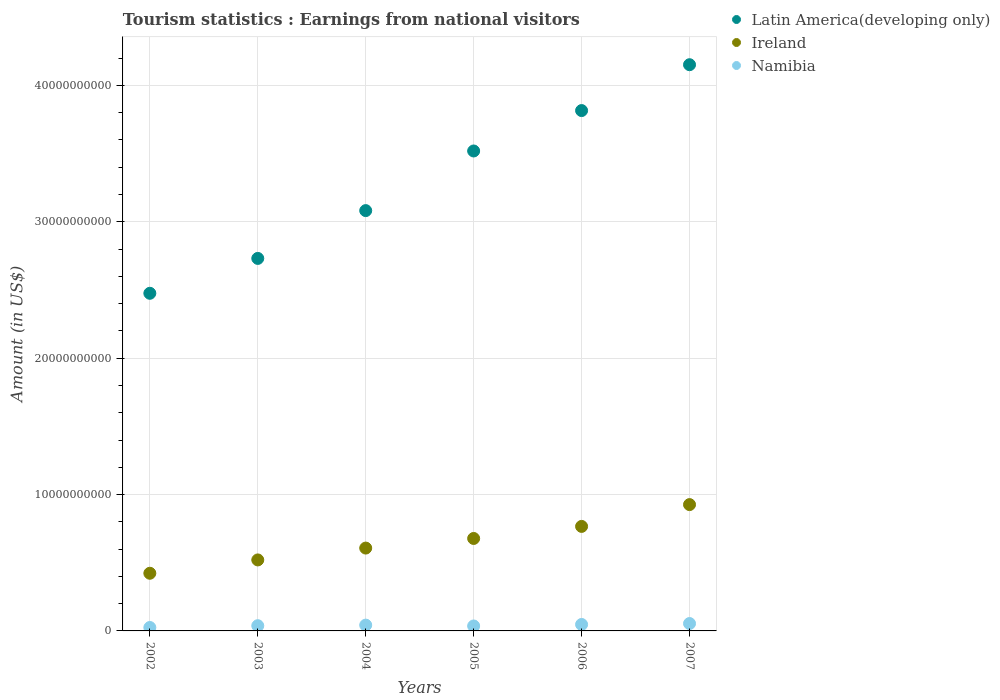How many different coloured dotlines are there?
Your answer should be compact. 3. Is the number of dotlines equal to the number of legend labels?
Provide a succinct answer. Yes. What is the earnings from national visitors in Namibia in 2006?
Offer a terse response. 4.73e+08. Across all years, what is the maximum earnings from national visitors in Namibia?
Your answer should be very brief. 5.42e+08. Across all years, what is the minimum earnings from national visitors in Latin America(developing only)?
Offer a very short reply. 2.48e+1. In which year was the earnings from national visitors in Ireland maximum?
Offer a terse response. 2007. In which year was the earnings from national visitors in Latin America(developing only) minimum?
Keep it short and to the point. 2002. What is the total earnings from national visitors in Ireland in the graph?
Your response must be concise. 3.92e+1. What is the difference between the earnings from national visitors in Latin America(developing only) in 2002 and that in 2007?
Give a very brief answer. -1.68e+1. What is the difference between the earnings from national visitors in Latin America(developing only) in 2003 and the earnings from national visitors in Ireland in 2005?
Offer a terse response. 2.05e+1. What is the average earnings from national visitors in Ireland per year?
Ensure brevity in your answer.  6.54e+09. In the year 2002, what is the difference between the earnings from national visitors in Latin America(developing only) and earnings from national visitors in Namibia?
Give a very brief answer. 2.45e+1. What is the ratio of the earnings from national visitors in Namibia in 2003 to that in 2006?
Your answer should be compact. 0.81. Is the earnings from national visitors in Namibia in 2004 less than that in 2006?
Provide a short and direct response. Yes. What is the difference between the highest and the second highest earnings from national visitors in Ireland?
Make the answer very short. 1.60e+09. What is the difference between the highest and the lowest earnings from national visitors in Namibia?
Your response must be concise. 2.91e+08. Is the sum of the earnings from national visitors in Latin America(developing only) in 2003 and 2006 greater than the maximum earnings from national visitors in Ireland across all years?
Provide a short and direct response. Yes. Is it the case that in every year, the sum of the earnings from national visitors in Ireland and earnings from national visitors in Namibia  is greater than the earnings from national visitors in Latin America(developing only)?
Give a very brief answer. No. Does the earnings from national visitors in Namibia monotonically increase over the years?
Ensure brevity in your answer.  No. Is the earnings from national visitors in Ireland strictly greater than the earnings from national visitors in Latin America(developing only) over the years?
Provide a short and direct response. No. Is the earnings from national visitors in Namibia strictly less than the earnings from national visitors in Ireland over the years?
Your response must be concise. Yes. Are the values on the major ticks of Y-axis written in scientific E-notation?
Provide a short and direct response. No. Does the graph contain any zero values?
Ensure brevity in your answer.  No. How many legend labels are there?
Make the answer very short. 3. How are the legend labels stacked?
Make the answer very short. Vertical. What is the title of the graph?
Your answer should be very brief. Tourism statistics : Earnings from national visitors. Does "Middle East & North Africa (all income levels)" appear as one of the legend labels in the graph?
Your response must be concise. No. What is the Amount (in US$) in Latin America(developing only) in 2002?
Offer a very short reply. 2.48e+1. What is the Amount (in US$) in Ireland in 2002?
Offer a very short reply. 4.23e+09. What is the Amount (in US$) in Namibia in 2002?
Make the answer very short. 2.51e+08. What is the Amount (in US$) in Latin America(developing only) in 2003?
Make the answer very short. 2.73e+1. What is the Amount (in US$) of Ireland in 2003?
Make the answer very short. 5.21e+09. What is the Amount (in US$) in Namibia in 2003?
Make the answer very short. 3.83e+08. What is the Amount (in US$) of Latin America(developing only) in 2004?
Ensure brevity in your answer.  3.08e+1. What is the Amount (in US$) in Ireland in 2004?
Your answer should be compact. 6.08e+09. What is the Amount (in US$) in Namibia in 2004?
Provide a succinct answer. 4.26e+08. What is the Amount (in US$) in Latin America(developing only) in 2005?
Your response must be concise. 3.52e+1. What is the Amount (in US$) in Ireland in 2005?
Your answer should be compact. 6.78e+09. What is the Amount (in US$) of Namibia in 2005?
Ensure brevity in your answer.  3.63e+08. What is the Amount (in US$) in Latin America(developing only) in 2006?
Your answer should be very brief. 3.82e+1. What is the Amount (in US$) of Ireland in 2006?
Your answer should be compact. 7.66e+09. What is the Amount (in US$) of Namibia in 2006?
Ensure brevity in your answer.  4.73e+08. What is the Amount (in US$) of Latin America(developing only) in 2007?
Your response must be concise. 4.15e+1. What is the Amount (in US$) in Ireland in 2007?
Your answer should be compact. 9.26e+09. What is the Amount (in US$) of Namibia in 2007?
Give a very brief answer. 5.42e+08. Across all years, what is the maximum Amount (in US$) in Latin America(developing only)?
Your response must be concise. 4.15e+1. Across all years, what is the maximum Amount (in US$) in Ireland?
Make the answer very short. 9.26e+09. Across all years, what is the maximum Amount (in US$) of Namibia?
Give a very brief answer. 5.42e+08. Across all years, what is the minimum Amount (in US$) in Latin America(developing only)?
Offer a very short reply. 2.48e+1. Across all years, what is the minimum Amount (in US$) of Ireland?
Your answer should be compact. 4.23e+09. Across all years, what is the minimum Amount (in US$) in Namibia?
Offer a very short reply. 2.51e+08. What is the total Amount (in US$) in Latin America(developing only) in the graph?
Provide a short and direct response. 1.98e+11. What is the total Amount (in US$) in Ireland in the graph?
Make the answer very short. 3.92e+1. What is the total Amount (in US$) of Namibia in the graph?
Provide a succinct answer. 2.44e+09. What is the difference between the Amount (in US$) in Latin America(developing only) in 2002 and that in 2003?
Your answer should be very brief. -2.56e+09. What is the difference between the Amount (in US$) of Ireland in 2002 and that in 2003?
Your answer should be very brief. -9.78e+08. What is the difference between the Amount (in US$) of Namibia in 2002 and that in 2003?
Give a very brief answer. -1.32e+08. What is the difference between the Amount (in US$) of Latin America(developing only) in 2002 and that in 2004?
Ensure brevity in your answer.  -6.06e+09. What is the difference between the Amount (in US$) of Ireland in 2002 and that in 2004?
Offer a terse response. -1.85e+09. What is the difference between the Amount (in US$) in Namibia in 2002 and that in 2004?
Your answer should be compact. -1.75e+08. What is the difference between the Amount (in US$) of Latin America(developing only) in 2002 and that in 2005?
Offer a terse response. -1.04e+1. What is the difference between the Amount (in US$) in Ireland in 2002 and that in 2005?
Ensure brevity in your answer.  -2.55e+09. What is the difference between the Amount (in US$) in Namibia in 2002 and that in 2005?
Provide a succinct answer. -1.12e+08. What is the difference between the Amount (in US$) of Latin America(developing only) in 2002 and that in 2006?
Ensure brevity in your answer.  -1.34e+1. What is the difference between the Amount (in US$) of Ireland in 2002 and that in 2006?
Keep it short and to the point. -3.44e+09. What is the difference between the Amount (in US$) of Namibia in 2002 and that in 2006?
Your answer should be very brief. -2.22e+08. What is the difference between the Amount (in US$) in Latin America(developing only) in 2002 and that in 2007?
Give a very brief answer. -1.68e+1. What is the difference between the Amount (in US$) of Ireland in 2002 and that in 2007?
Provide a succinct answer. -5.04e+09. What is the difference between the Amount (in US$) in Namibia in 2002 and that in 2007?
Offer a terse response. -2.91e+08. What is the difference between the Amount (in US$) in Latin America(developing only) in 2003 and that in 2004?
Provide a succinct answer. -3.50e+09. What is the difference between the Amount (in US$) in Ireland in 2003 and that in 2004?
Your answer should be compact. -8.69e+08. What is the difference between the Amount (in US$) of Namibia in 2003 and that in 2004?
Offer a very short reply. -4.30e+07. What is the difference between the Amount (in US$) in Latin America(developing only) in 2003 and that in 2005?
Provide a short and direct response. -7.88e+09. What is the difference between the Amount (in US$) in Ireland in 2003 and that in 2005?
Provide a short and direct response. -1.57e+09. What is the difference between the Amount (in US$) in Latin America(developing only) in 2003 and that in 2006?
Offer a very short reply. -1.08e+1. What is the difference between the Amount (in US$) of Ireland in 2003 and that in 2006?
Provide a succinct answer. -2.46e+09. What is the difference between the Amount (in US$) in Namibia in 2003 and that in 2006?
Provide a short and direct response. -9.00e+07. What is the difference between the Amount (in US$) of Latin America(developing only) in 2003 and that in 2007?
Your response must be concise. -1.42e+1. What is the difference between the Amount (in US$) in Ireland in 2003 and that in 2007?
Provide a short and direct response. -4.06e+09. What is the difference between the Amount (in US$) in Namibia in 2003 and that in 2007?
Your answer should be compact. -1.59e+08. What is the difference between the Amount (in US$) in Latin America(developing only) in 2004 and that in 2005?
Make the answer very short. -4.37e+09. What is the difference between the Amount (in US$) in Ireland in 2004 and that in 2005?
Your answer should be compact. -7.05e+08. What is the difference between the Amount (in US$) in Namibia in 2004 and that in 2005?
Make the answer very short. 6.30e+07. What is the difference between the Amount (in US$) of Latin America(developing only) in 2004 and that in 2006?
Keep it short and to the point. -7.34e+09. What is the difference between the Amount (in US$) in Ireland in 2004 and that in 2006?
Ensure brevity in your answer.  -1.59e+09. What is the difference between the Amount (in US$) in Namibia in 2004 and that in 2006?
Offer a terse response. -4.70e+07. What is the difference between the Amount (in US$) in Latin America(developing only) in 2004 and that in 2007?
Ensure brevity in your answer.  -1.07e+1. What is the difference between the Amount (in US$) in Ireland in 2004 and that in 2007?
Your answer should be very brief. -3.19e+09. What is the difference between the Amount (in US$) of Namibia in 2004 and that in 2007?
Keep it short and to the point. -1.16e+08. What is the difference between the Amount (in US$) in Latin America(developing only) in 2005 and that in 2006?
Keep it short and to the point. -2.96e+09. What is the difference between the Amount (in US$) in Ireland in 2005 and that in 2006?
Ensure brevity in your answer.  -8.84e+08. What is the difference between the Amount (in US$) of Namibia in 2005 and that in 2006?
Provide a short and direct response. -1.10e+08. What is the difference between the Amount (in US$) in Latin America(developing only) in 2005 and that in 2007?
Ensure brevity in your answer.  -6.33e+09. What is the difference between the Amount (in US$) of Ireland in 2005 and that in 2007?
Make the answer very short. -2.48e+09. What is the difference between the Amount (in US$) in Namibia in 2005 and that in 2007?
Provide a short and direct response. -1.79e+08. What is the difference between the Amount (in US$) of Latin America(developing only) in 2006 and that in 2007?
Offer a terse response. -3.36e+09. What is the difference between the Amount (in US$) in Ireland in 2006 and that in 2007?
Your answer should be compact. -1.60e+09. What is the difference between the Amount (in US$) in Namibia in 2006 and that in 2007?
Provide a succinct answer. -6.90e+07. What is the difference between the Amount (in US$) in Latin America(developing only) in 2002 and the Amount (in US$) in Ireland in 2003?
Your response must be concise. 1.96e+1. What is the difference between the Amount (in US$) of Latin America(developing only) in 2002 and the Amount (in US$) of Namibia in 2003?
Your answer should be very brief. 2.44e+1. What is the difference between the Amount (in US$) in Ireland in 2002 and the Amount (in US$) in Namibia in 2003?
Offer a terse response. 3.84e+09. What is the difference between the Amount (in US$) of Latin America(developing only) in 2002 and the Amount (in US$) of Ireland in 2004?
Your answer should be compact. 1.87e+1. What is the difference between the Amount (in US$) of Latin America(developing only) in 2002 and the Amount (in US$) of Namibia in 2004?
Give a very brief answer. 2.43e+1. What is the difference between the Amount (in US$) of Ireland in 2002 and the Amount (in US$) of Namibia in 2004?
Your answer should be compact. 3.80e+09. What is the difference between the Amount (in US$) of Latin America(developing only) in 2002 and the Amount (in US$) of Ireland in 2005?
Provide a succinct answer. 1.80e+1. What is the difference between the Amount (in US$) in Latin America(developing only) in 2002 and the Amount (in US$) in Namibia in 2005?
Ensure brevity in your answer.  2.44e+1. What is the difference between the Amount (in US$) in Ireland in 2002 and the Amount (in US$) in Namibia in 2005?
Keep it short and to the point. 3.86e+09. What is the difference between the Amount (in US$) in Latin America(developing only) in 2002 and the Amount (in US$) in Ireland in 2006?
Your answer should be compact. 1.71e+1. What is the difference between the Amount (in US$) in Latin America(developing only) in 2002 and the Amount (in US$) in Namibia in 2006?
Your answer should be compact. 2.43e+1. What is the difference between the Amount (in US$) of Ireland in 2002 and the Amount (in US$) of Namibia in 2006?
Ensure brevity in your answer.  3.76e+09. What is the difference between the Amount (in US$) of Latin America(developing only) in 2002 and the Amount (in US$) of Ireland in 2007?
Your response must be concise. 1.55e+1. What is the difference between the Amount (in US$) of Latin America(developing only) in 2002 and the Amount (in US$) of Namibia in 2007?
Your answer should be compact. 2.42e+1. What is the difference between the Amount (in US$) of Ireland in 2002 and the Amount (in US$) of Namibia in 2007?
Provide a succinct answer. 3.69e+09. What is the difference between the Amount (in US$) of Latin America(developing only) in 2003 and the Amount (in US$) of Ireland in 2004?
Offer a terse response. 2.12e+1. What is the difference between the Amount (in US$) in Latin America(developing only) in 2003 and the Amount (in US$) in Namibia in 2004?
Provide a succinct answer. 2.69e+1. What is the difference between the Amount (in US$) in Ireland in 2003 and the Amount (in US$) in Namibia in 2004?
Make the answer very short. 4.78e+09. What is the difference between the Amount (in US$) in Latin America(developing only) in 2003 and the Amount (in US$) in Ireland in 2005?
Offer a terse response. 2.05e+1. What is the difference between the Amount (in US$) in Latin America(developing only) in 2003 and the Amount (in US$) in Namibia in 2005?
Keep it short and to the point. 2.70e+1. What is the difference between the Amount (in US$) in Ireland in 2003 and the Amount (in US$) in Namibia in 2005?
Ensure brevity in your answer.  4.84e+09. What is the difference between the Amount (in US$) of Latin America(developing only) in 2003 and the Amount (in US$) of Ireland in 2006?
Make the answer very short. 1.97e+1. What is the difference between the Amount (in US$) of Latin America(developing only) in 2003 and the Amount (in US$) of Namibia in 2006?
Make the answer very short. 2.68e+1. What is the difference between the Amount (in US$) of Ireland in 2003 and the Amount (in US$) of Namibia in 2006?
Provide a short and direct response. 4.73e+09. What is the difference between the Amount (in US$) of Latin America(developing only) in 2003 and the Amount (in US$) of Ireland in 2007?
Offer a terse response. 1.81e+1. What is the difference between the Amount (in US$) of Latin America(developing only) in 2003 and the Amount (in US$) of Namibia in 2007?
Give a very brief answer. 2.68e+1. What is the difference between the Amount (in US$) in Ireland in 2003 and the Amount (in US$) in Namibia in 2007?
Provide a short and direct response. 4.66e+09. What is the difference between the Amount (in US$) of Latin America(developing only) in 2004 and the Amount (in US$) of Ireland in 2005?
Offer a terse response. 2.40e+1. What is the difference between the Amount (in US$) of Latin America(developing only) in 2004 and the Amount (in US$) of Namibia in 2005?
Provide a succinct answer. 3.05e+1. What is the difference between the Amount (in US$) in Ireland in 2004 and the Amount (in US$) in Namibia in 2005?
Provide a short and direct response. 5.71e+09. What is the difference between the Amount (in US$) in Latin America(developing only) in 2004 and the Amount (in US$) in Ireland in 2006?
Offer a very short reply. 2.32e+1. What is the difference between the Amount (in US$) in Latin America(developing only) in 2004 and the Amount (in US$) in Namibia in 2006?
Offer a terse response. 3.03e+1. What is the difference between the Amount (in US$) in Ireland in 2004 and the Amount (in US$) in Namibia in 2006?
Give a very brief answer. 5.60e+09. What is the difference between the Amount (in US$) in Latin America(developing only) in 2004 and the Amount (in US$) in Ireland in 2007?
Make the answer very short. 2.16e+1. What is the difference between the Amount (in US$) in Latin America(developing only) in 2004 and the Amount (in US$) in Namibia in 2007?
Offer a very short reply. 3.03e+1. What is the difference between the Amount (in US$) in Ireland in 2004 and the Amount (in US$) in Namibia in 2007?
Provide a short and direct response. 5.53e+09. What is the difference between the Amount (in US$) of Latin America(developing only) in 2005 and the Amount (in US$) of Ireland in 2006?
Provide a succinct answer. 2.75e+1. What is the difference between the Amount (in US$) in Latin America(developing only) in 2005 and the Amount (in US$) in Namibia in 2006?
Offer a very short reply. 3.47e+1. What is the difference between the Amount (in US$) of Ireland in 2005 and the Amount (in US$) of Namibia in 2006?
Give a very brief answer. 6.31e+09. What is the difference between the Amount (in US$) in Latin America(developing only) in 2005 and the Amount (in US$) in Ireland in 2007?
Provide a succinct answer. 2.59e+1. What is the difference between the Amount (in US$) of Latin America(developing only) in 2005 and the Amount (in US$) of Namibia in 2007?
Make the answer very short. 3.47e+1. What is the difference between the Amount (in US$) in Ireland in 2005 and the Amount (in US$) in Namibia in 2007?
Offer a terse response. 6.24e+09. What is the difference between the Amount (in US$) of Latin America(developing only) in 2006 and the Amount (in US$) of Ireland in 2007?
Keep it short and to the point. 2.89e+1. What is the difference between the Amount (in US$) of Latin America(developing only) in 2006 and the Amount (in US$) of Namibia in 2007?
Your response must be concise. 3.76e+1. What is the difference between the Amount (in US$) in Ireland in 2006 and the Amount (in US$) in Namibia in 2007?
Provide a succinct answer. 7.12e+09. What is the average Amount (in US$) in Latin America(developing only) per year?
Your response must be concise. 3.30e+1. What is the average Amount (in US$) of Ireland per year?
Make the answer very short. 6.54e+09. What is the average Amount (in US$) in Namibia per year?
Your answer should be very brief. 4.06e+08. In the year 2002, what is the difference between the Amount (in US$) of Latin America(developing only) and Amount (in US$) of Ireland?
Your response must be concise. 2.05e+1. In the year 2002, what is the difference between the Amount (in US$) of Latin America(developing only) and Amount (in US$) of Namibia?
Ensure brevity in your answer.  2.45e+1. In the year 2002, what is the difference between the Amount (in US$) of Ireland and Amount (in US$) of Namibia?
Give a very brief answer. 3.98e+09. In the year 2003, what is the difference between the Amount (in US$) of Latin America(developing only) and Amount (in US$) of Ireland?
Your answer should be compact. 2.21e+1. In the year 2003, what is the difference between the Amount (in US$) in Latin America(developing only) and Amount (in US$) in Namibia?
Make the answer very short. 2.69e+1. In the year 2003, what is the difference between the Amount (in US$) in Ireland and Amount (in US$) in Namibia?
Your answer should be compact. 4.82e+09. In the year 2004, what is the difference between the Amount (in US$) in Latin America(developing only) and Amount (in US$) in Ireland?
Keep it short and to the point. 2.47e+1. In the year 2004, what is the difference between the Amount (in US$) in Latin America(developing only) and Amount (in US$) in Namibia?
Give a very brief answer. 3.04e+1. In the year 2004, what is the difference between the Amount (in US$) in Ireland and Amount (in US$) in Namibia?
Provide a short and direct response. 5.65e+09. In the year 2005, what is the difference between the Amount (in US$) of Latin America(developing only) and Amount (in US$) of Ireland?
Provide a succinct answer. 2.84e+1. In the year 2005, what is the difference between the Amount (in US$) of Latin America(developing only) and Amount (in US$) of Namibia?
Your answer should be very brief. 3.48e+1. In the year 2005, what is the difference between the Amount (in US$) of Ireland and Amount (in US$) of Namibia?
Your answer should be compact. 6.42e+09. In the year 2006, what is the difference between the Amount (in US$) in Latin America(developing only) and Amount (in US$) in Ireland?
Give a very brief answer. 3.05e+1. In the year 2006, what is the difference between the Amount (in US$) in Latin America(developing only) and Amount (in US$) in Namibia?
Offer a very short reply. 3.77e+1. In the year 2006, what is the difference between the Amount (in US$) of Ireland and Amount (in US$) of Namibia?
Your answer should be very brief. 7.19e+09. In the year 2007, what is the difference between the Amount (in US$) of Latin America(developing only) and Amount (in US$) of Ireland?
Offer a very short reply. 3.23e+1. In the year 2007, what is the difference between the Amount (in US$) in Latin America(developing only) and Amount (in US$) in Namibia?
Make the answer very short. 4.10e+1. In the year 2007, what is the difference between the Amount (in US$) of Ireland and Amount (in US$) of Namibia?
Your answer should be very brief. 8.72e+09. What is the ratio of the Amount (in US$) of Latin America(developing only) in 2002 to that in 2003?
Make the answer very short. 0.91. What is the ratio of the Amount (in US$) of Ireland in 2002 to that in 2003?
Give a very brief answer. 0.81. What is the ratio of the Amount (in US$) of Namibia in 2002 to that in 2003?
Offer a terse response. 0.66. What is the ratio of the Amount (in US$) in Latin America(developing only) in 2002 to that in 2004?
Offer a very short reply. 0.8. What is the ratio of the Amount (in US$) of Ireland in 2002 to that in 2004?
Give a very brief answer. 0.7. What is the ratio of the Amount (in US$) of Namibia in 2002 to that in 2004?
Provide a succinct answer. 0.59. What is the ratio of the Amount (in US$) in Latin America(developing only) in 2002 to that in 2005?
Provide a succinct answer. 0.7. What is the ratio of the Amount (in US$) of Ireland in 2002 to that in 2005?
Offer a very short reply. 0.62. What is the ratio of the Amount (in US$) of Namibia in 2002 to that in 2005?
Provide a succinct answer. 0.69. What is the ratio of the Amount (in US$) in Latin America(developing only) in 2002 to that in 2006?
Provide a succinct answer. 0.65. What is the ratio of the Amount (in US$) in Ireland in 2002 to that in 2006?
Provide a short and direct response. 0.55. What is the ratio of the Amount (in US$) in Namibia in 2002 to that in 2006?
Ensure brevity in your answer.  0.53. What is the ratio of the Amount (in US$) in Latin America(developing only) in 2002 to that in 2007?
Provide a succinct answer. 0.6. What is the ratio of the Amount (in US$) in Ireland in 2002 to that in 2007?
Make the answer very short. 0.46. What is the ratio of the Amount (in US$) of Namibia in 2002 to that in 2007?
Offer a terse response. 0.46. What is the ratio of the Amount (in US$) in Latin America(developing only) in 2003 to that in 2004?
Give a very brief answer. 0.89. What is the ratio of the Amount (in US$) in Ireland in 2003 to that in 2004?
Your answer should be compact. 0.86. What is the ratio of the Amount (in US$) of Namibia in 2003 to that in 2004?
Give a very brief answer. 0.9. What is the ratio of the Amount (in US$) in Latin America(developing only) in 2003 to that in 2005?
Offer a terse response. 0.78. What is the ratio of the Amount (in US$) of Ireland in 2003 to that in 2005?
Provide a succinct answer. 0.77. What is the ratio of the Amount (in US$) of Namibia in 2003 to that in 2005?
Offer a terse response. 1.06. What is the ratio of the Amount (in US$) of Latin America(developing only) in 2003 to that in 2006?
Offer a very short reply. 0.72. What is the ratio of the Amount (in US$) of Ireland in 2003 to that in 2006?
Provide a succinct answer. 0.68. What is the ratio of the Amount (in US$) of Namibia in 2003 to that in 2006?
Provide a short and direct response. 0.81. What is the ratio of the Amount (in US$) of Latin America(developing only) in 2003 to that in 2007?
Keep it short and to the point. 0.66. What is the ratio of the Amount (in US$) of Ireland in 2003 to that in 2007?
Provide a succinct answer. 0.56. What is the ratio of the Amount (in US$) in Namibia in 2003 to that in 2007?
Ensure brevity in your answer.  0.71. What is the ratio of the Amount (in US$) in Latin America(developing only) in 2004 to that in 2005?
Offer a very short reply. 0.88. What is the ratio of the Amount (in US$) in Ireland in 2004 to that in 2005?
Give a very brief answer. 0.9. What is the ratio of the Amount (in US$) in Namibia in 2004 to that in 2005?
Your response must be concise. 1.17. What is the ratio of the Amount (in US$) in Latin America(developing only) in 2004 to that in 2006?
Give a very brief answer. 0.81. What is the ratio of the Amount (in US$) of Ireland in 2004 to that in 2006?
Your answer should be very brief. 0.79. What is the ratio of the Amount (in US$) of Namibia in 2004 to that in 2006?
Your answer should be very brief. 0.9. What is the ratio of the Amount (in US$) in Latin America(developing only) in 2004 to that in 2007?
Provide a succinct answer. 0.74. What is the ratio of the Amount (in US$) in Ireland in 2004 to that in 2007?
Your answer should be very brief. 0.66. What is the ratio of the Amount (in US$) in Namibia in 2004 to that in 2007?
Offer a very short reply. 0.79. What is the ratio of the Amount (in US$) of Latin America(developing only) in 2005 to that in 2006?
Make the answer very short. 0.92. What is the ratio of the Amount (in US$) in Ireland in 2005 to that in 2006?
Make the answer very short. 0.88. What is the ratio of the Amount (in US$) of Namibia in 2005 to that in 2006?
Your response must be concise. 0.77. What is the ratio of the Amount (in US$) of Latin America(developing only) in 2005 to that in 2007?
Offer a terse response. 0.85. What is the ratio of the Amount (in US$) of Ireland in 2005 to that in 2007?
Provide a short and direct response. 0.73. What is the ratio of the Amount (in US$) of Namibia in 2005 to that in 2007?
Your answer should be very brief. 0.67. What is the ratio of the Amount (in US$) in Latin America(developing only) in 2006 to that in 2007?
Keep it short and to the point. 0.92. What is the ratio of the Amount (in US$) of Ireland in 2006 to that in 2007?
Provide a short and direct response. 0.83. What is the ratio of the Amount (in US$) in Namibia in 2006 to that in 2007?
Keep it short and to the point. 0.87. What is the difference between the highest and the second highest Amount (in US$) of Latin America(developing only)?
Provide a succinct answer. 3.36e+09. What is the difference between the highest and the second highest Amount (in US$) of Ireland?
Your answer should be very brief. 1.60e+09. What is the difference between the highest and the second highest Amount (in US$) in Namibia?
Ensure brevity in your answer.  6.90e+07. What is the difference between the highest and the lowest Amount (in US$) of Latin America(developing only)?
Keep it short and to the point. 1.68e+1. What is the difference between the highest and the lowest Amount (in US$) of Ireland?
Your response must be concise. 5.04e+09. What is the difference between the highest and the lowest Amount (in US$) in Namibia?
Make the answer very short. 2.91e+08. 